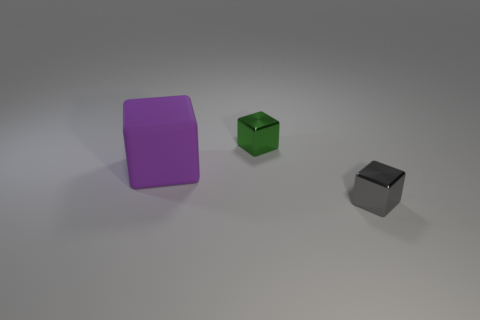Subtract all green blocks. Subtract all blue cylinders. How many blocks are left? 2 Add 3 matte spheres. How many objects exist? 6 Add 2 small objects. How many small objects exist? 4 Subtract 1 gray cubes. How many objects are left? 2 Subtract all small cyan rubber cylinders. Subtract all cubes. How many objects are left? 0 Add 1 big purple things. How many big purple things are left? 2 